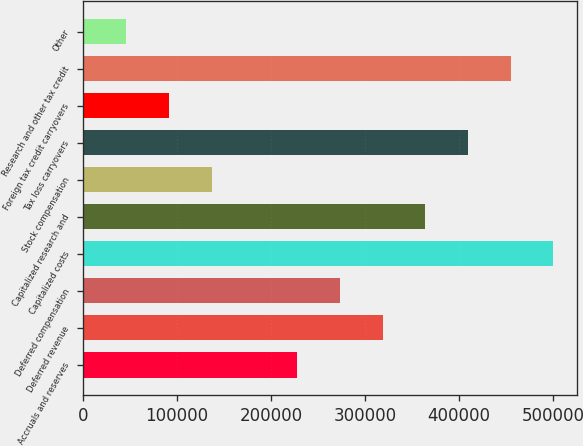<chart> <loc_0><loc_0><loc_500><loc_500><bar_chart><fcel>Accruals and reserves<fcel>Deferred revenue<fcel>Deferred compensation<fcel>Capitalized costs<fcel>Capitalized research and<fcel>Stock compensation<fcel>Tax loss carryovers<fcel>Foreign tax credit carryovers<fcel>Research and other tax credit<fcel>Other<nl><fcel>227790<fcel>318574<fcel>273182<fcel>500141<fcel>363965<fcel>137006<fcel>409357<fcel>91614.6<fcel>454749<fcel>46222.8<nl></chart> 